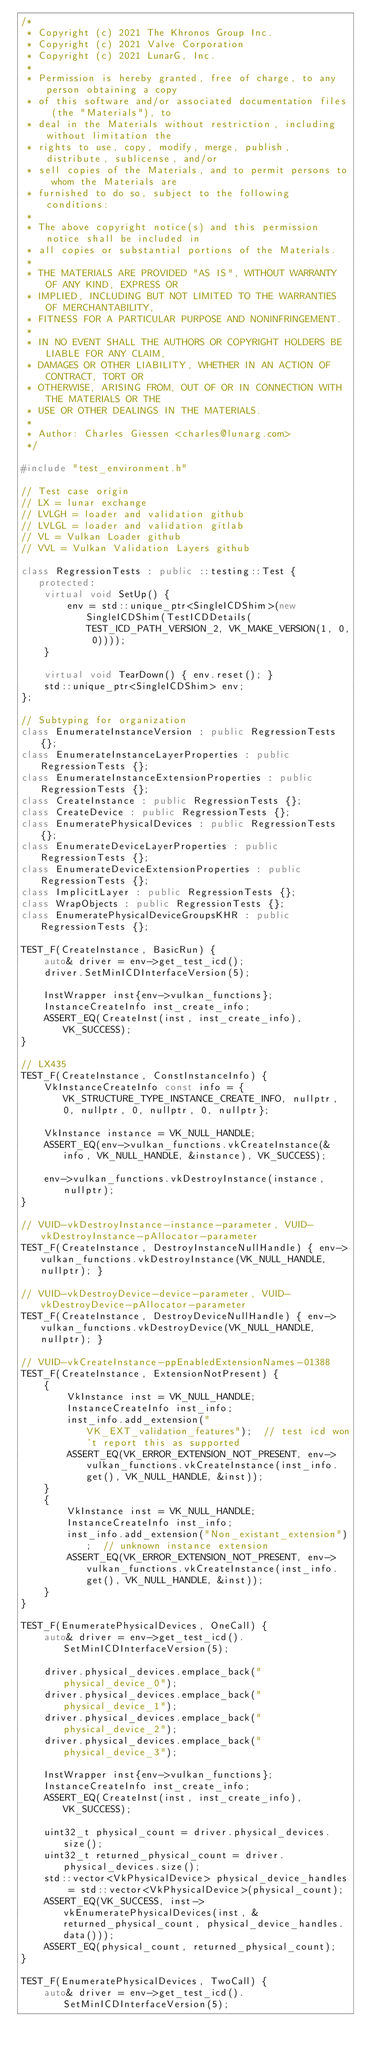Convert code to text. <code><loc_0><loc_0><loc_500><loc_500><_C++_>/*
 * Copyright (c) 2021 The Khronos Group Inc.
 * Copyright (c) 2021 Valve Corporation
 * Copyright (c) 2021 LunarG, Inc.
 *
 * Permission is hereby granted, free of charge, to any person obtaining a copy
 * of this software and/or associated documentation files (the "Materials"), to
 * deal in the Materials without restriction, including without limitation the
 * rights to use, copy, modify, merge, publish, distribute, sublicense, and/or
 * sell copies of the Materials, and to permit persons to whom the Materials are
 * furnished to do so, subject to the following conditions:
 *
 * The above copyright notice(s) and this permission notice shall be included in
 * all copies or substantial portions of the Materials.
 *
 * THE MATERIALS ARE PROVIDED "AS IS", WITHOUT WARRANTY OF ANY KIND, EXPRESS OR
 * IMPLIED, INCLUDING BUT NOT LIMITED TO THE WARRANTIES OF MERCHANTABILITY,
 * FITNESS FOR A PARTICULAR PURPOSE AND NONINFRINGEMENT.
 *
 * IN NO EVENT SHALL THE AUTHORS OR COPYRIGHT HOLDERS BE LIABLE FOR ANY CLAIM,
 * DAMAGES OR OTHER LIABILITY, WHETHER IN AN ACTION OF CONTRACT, TORT OR
 * OTHERWISE, ARISING FROM, OUT OF OR IN CONNECTION WITH THE MATERIALS OR THE
 * USE OR OTHER DEALINGS IN THE MATERIALS.
 *
 * Author: Charles Giessen <charles@lunarg.com>
 */

#include "test_environment.h"

// Test case origin
// LX = lunar exchange
// LVLGH = loader and validation github
// LVLGL = loader and validation gitlab
// VL = Vulkan Loader github
// VVL = Vulkan Validation Layers github

class RegressionTests : public ::testing::Test {
   protected:
    virtual void SetUp() {
        env = std::unique_ptr<SingleICDShim>(new SingleICDShim(TestICDDetails(TEST_ICD_PATH_VERSION_2, VK_MAKE_VERSION(1, 0, 0))));
    }

    virtual void TearDown() { env.reset(); }
    std::unique_ptr<SingleICDShim> env;
};

// Subtyping for organization
class EnumerateInstanceVersion : public RegressionTests {};
class EnumerateInstanceLayerProperties : public RegressionTests {};
class EnumerateInstanceExtensionProperties : public RegressionTests {};
class CreateInstance : public RegressionTests {};
class CreateDevice : public RegressionTests {};
class EnumeratePhysicalDevices : public RegressionTests {};
class EnumerateDeviceLayerProperties : public RegressionTests {};
class EnumerateDeviceExtensionProperties : public RegressionTests {};
class ImplicitLayer : public RegressionTests {};
class WrapObjects : public RegressionTests {};
class EnumeratePhysicalDeviceGroupsKHR : public RegressionTests {};

TEST_F(CreateInstance, BasicRun) {
    auto& driver = env->get_test_icd();
    driver.SetMinICDInterfaceVersion(5);

    InstWrapper inst{env->vulkan_functions};
    InstanceCreateInfo inst_create_info;
    ASSERT_EQ(CreateInst(inst, inst_create_info), VK_SUCCESS);
}

// LX435
TEST_F(CreateInstance, ConstInstanceInfo) {
    VkInstanceCreateInfo const info = {VK_STRUCTURE_TYPE_INSTANCE_CREATE_INFO, nullptr, 0, nullptr, 0, nullptr, 0, nullptr};

    VkInstance instance = VK_NULL_HANDLE;
    ASSERT_EQ(env->vulkan_functions.vkCreateInstance(&info, VK_NULL_HANDLE, &instance), VK_SUCCESS);

    env->vulkan_functions.vkDestroyInstance(instance, nullptr);
}

// VUID-vkDestroyInstance-instance-parameter, VUID-vkDestroyInstance-pAllocator-parameter
TEST_F(CreateInstance, DestroyInstanceNullHandle) { env->vulkan_functions.vkDestroyInstance(VK_NULL_HANDLE, nullptr); }

// VUID-vkDestroyDevice-device-parameter, VUID-vkDestroyDevice-pAllocator-parameter
TEST_F(CreateInstance, DestroyDeviceNullHandle) { env->vulkan_functions.vkDestroyDevice(VK_NULL_HANDLE, nullptr); }

// VUID-vkCreateInstance-ppEnabledExtensionNames-01388
TEST_F(CreateInstance, ExtensionNotPresent) {
    {
        VkInstance inst = VK_NULL_HANDLE;
        InstanceCreateInfo inst_info;
        inst_info.add_extension("VK_EXT_validation_features");  // test icd won't report this as supported
        ASSERT_EQ(VK_ERROR_EXTENSION_NOT_PRESENT, env->vulkan_functions.vkCreateInstance(inst_info.get(), VK_NULL_HANDLE, &inst));
    }
    {
        VkInstance inst = VK_NULL_HANDLE;
        InstanceCreateInfo inst_info;
        inst_info.add_extension("Non_existant_extension");  // unknown instance extension
        ASSERT_EQ(VK_ERROR_EXTENSION_NOT_PRESENT, env->vulkan_functions.vkCreateInstance(inst_info.get(), VK_NULL_HANDLE, &inst));
    }
}

TEST_F(EnumeratePhysicalDevices, OneCall) {
    auto& driver = env->get_test_icd().SetMinICDInterfaceVersion(5);

    driver.physical_devices.emplace_back("physical_device_0");
    driver.physical_devices.emplace_back("physical_device_1");
    driver.physical_devices.emplace_back("physical_device_2");
    driver.physical_devices.emplace_back("physical_device_3");

    InstWrapper inst{env->vulkan_functions};
    InstanceCreateInfo inst_create_info;
    ASSERT_EQ(CreateInst(inst, inst_create_info), VK_SUCCESS);

    uint32_t physical_count = driver.physical_devices.size();
    uint32_t returned_physical_count = driver.physical_devices.size();
    std::vector<VkPhysicalDevice> physical_device_handles = std::vector<VkPhysicalDevice>(physical_count);
    ASSERT_EQ(VK_SUCCESS, inst->vkEnumeratePhysicalDevices(inst, &returned_physical_count, physical_device_handles.data()));
    ASSERT_EQ(physical_count, returned_physical_count);
}

TEST_F(EnumeratePhysicalDevices, TwoCall) {
    auto& driver = env->get_test_icd().SetMinICDInterfaceVersion(5);
</code> 